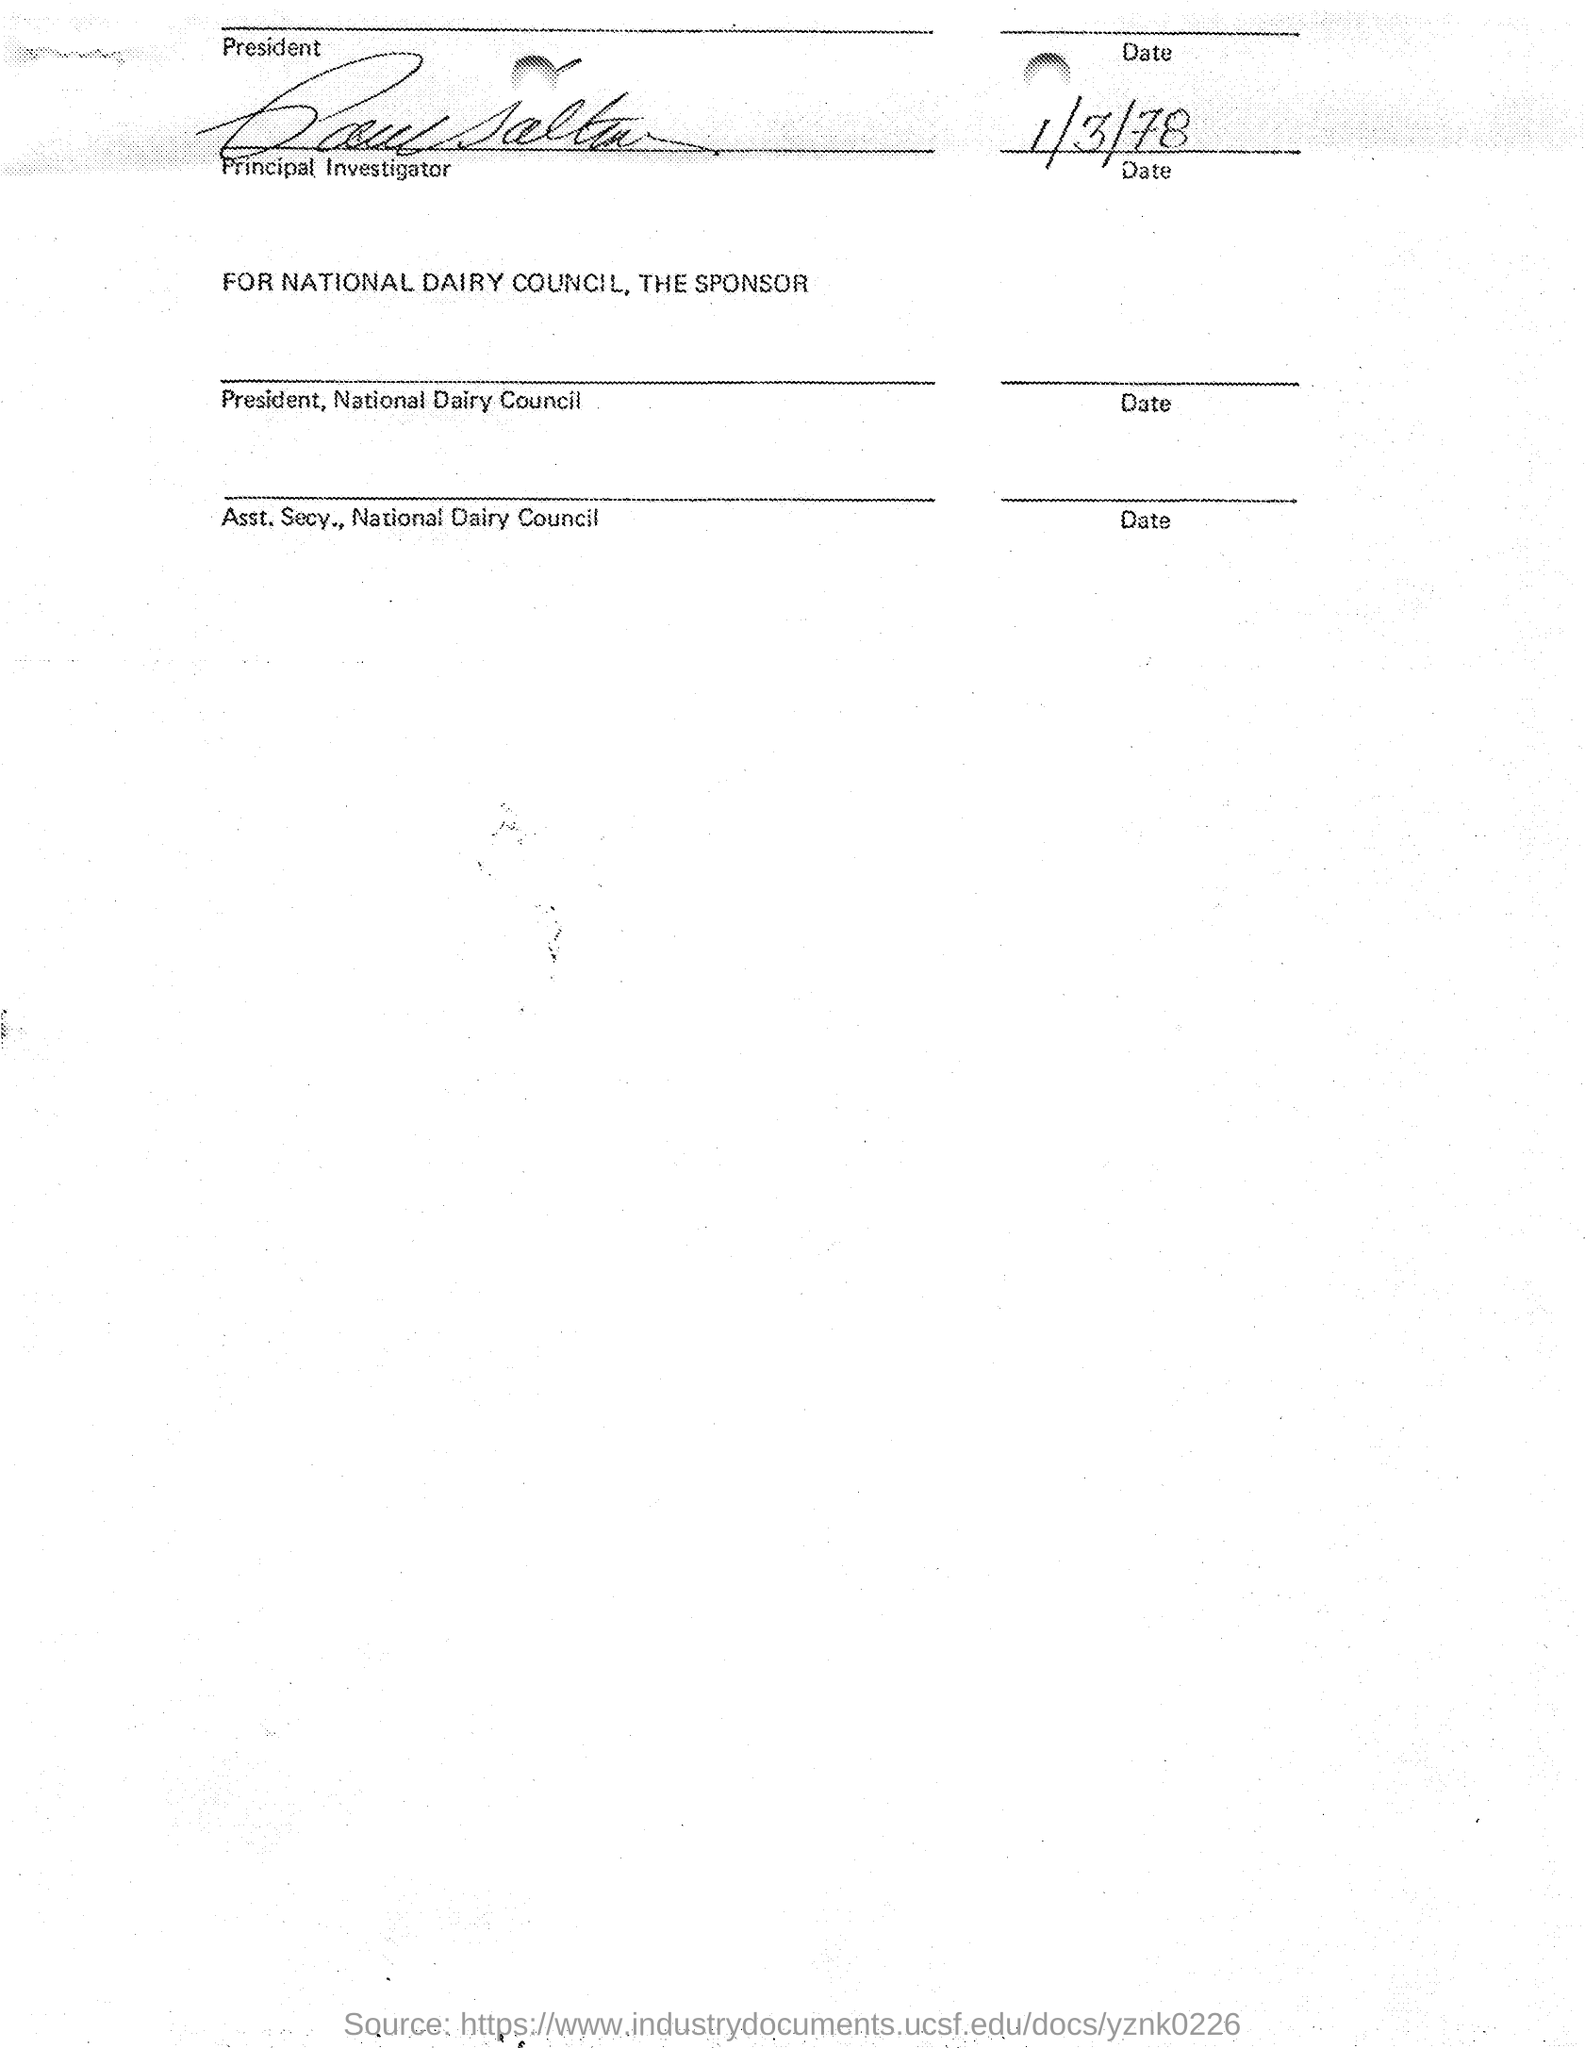Draw attention to some important aspects in this diagram. The date mentioned in the document is 1/3/78. 